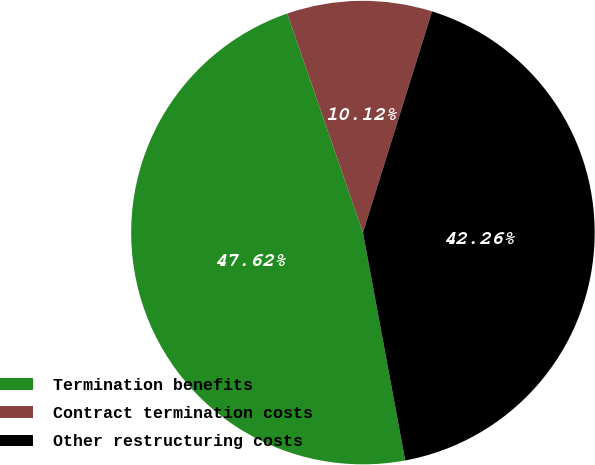Convert chart. <chart><loc_0><loc_0><loc_500><loc_500><pie_chart><fcel>Termination benefits<fcel>Contract termination costs<fcel>Other restructuring costs<nl><fcel>47.62%<fcel>10.12%<fcel>42.26%<nl></chart> 